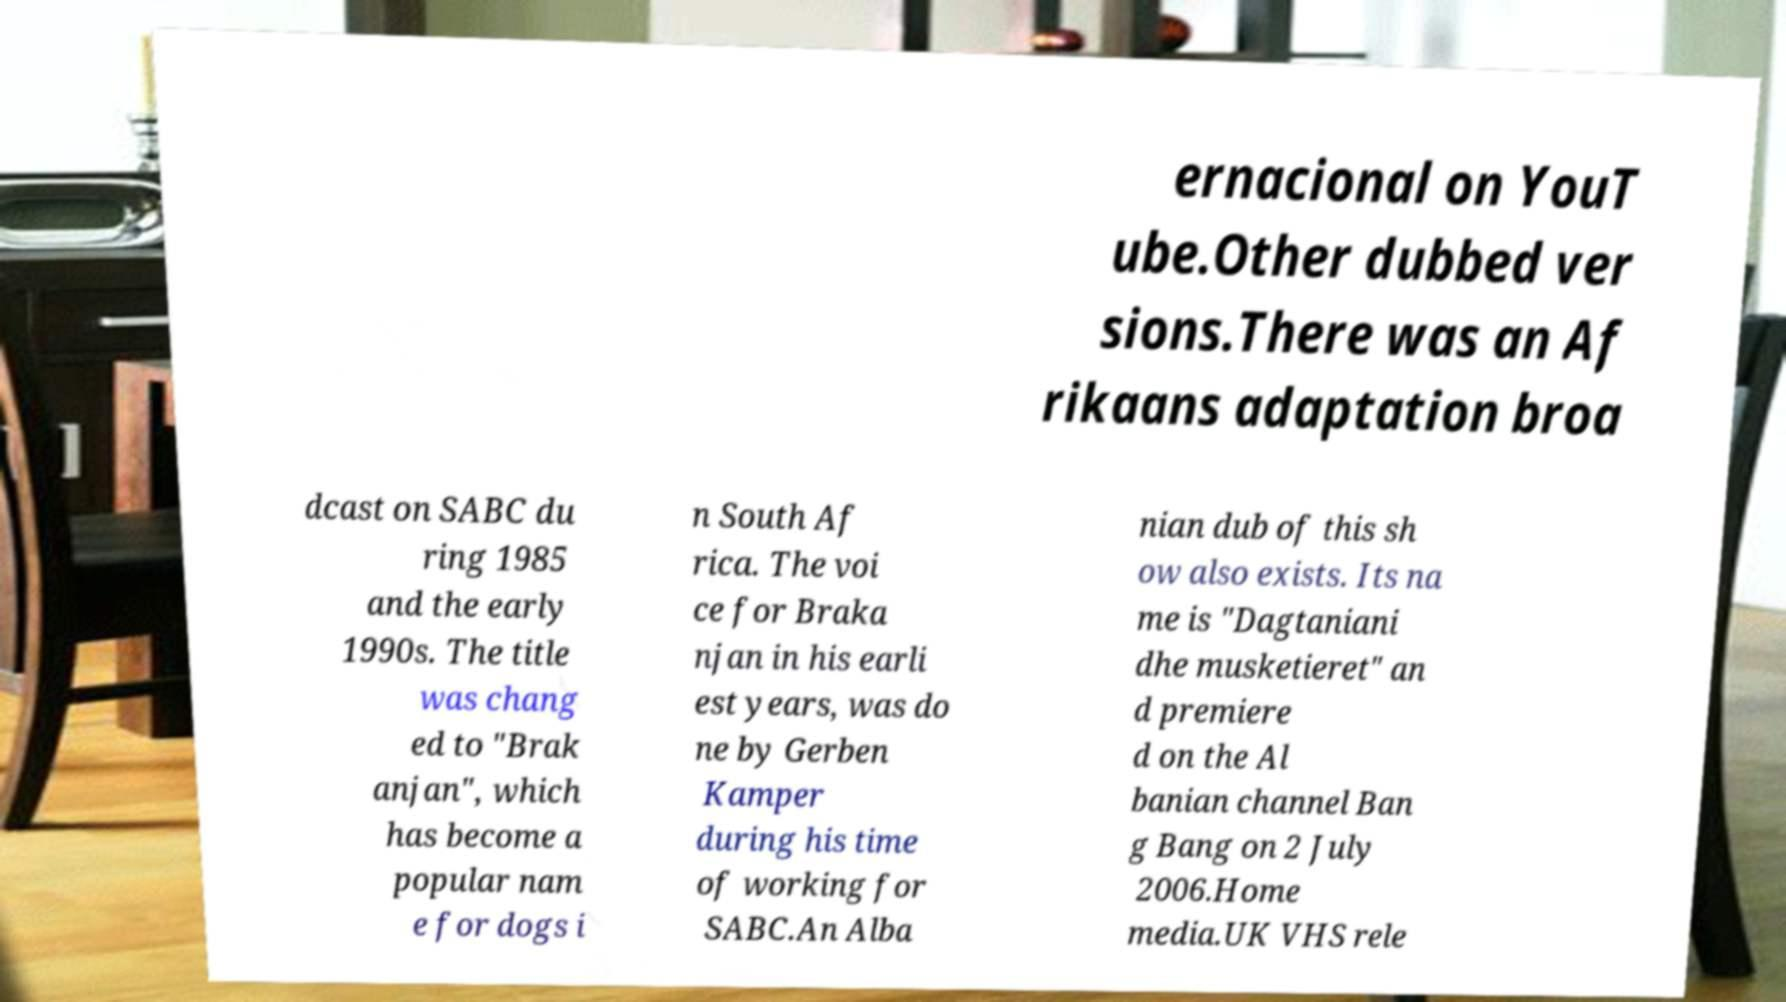Can you read and provide the text displayed in the image?This photo seems to have some interesting text. Can you extract and type it out for me? ernacional on YouT ube.Other dubbed ver sions.There was an Af rikaans adaptation broa dcast on SABC du ring 1985 and the early 1990s. The title was chang ed to "Brak anjan", which has become a popular nam e for dogs i n South Af rica. The voi ce for Braka njan in his earli est years, was do ne by Gerben Kamper during his time of working for SABC.An Alba nian dub of this sh ow also exists. Its na me is "Dagtaniani dhe musketieret" an d premiere d on the Al banian channel Ban g Bang on 2 July 2006.Home media.UK VHS rele 